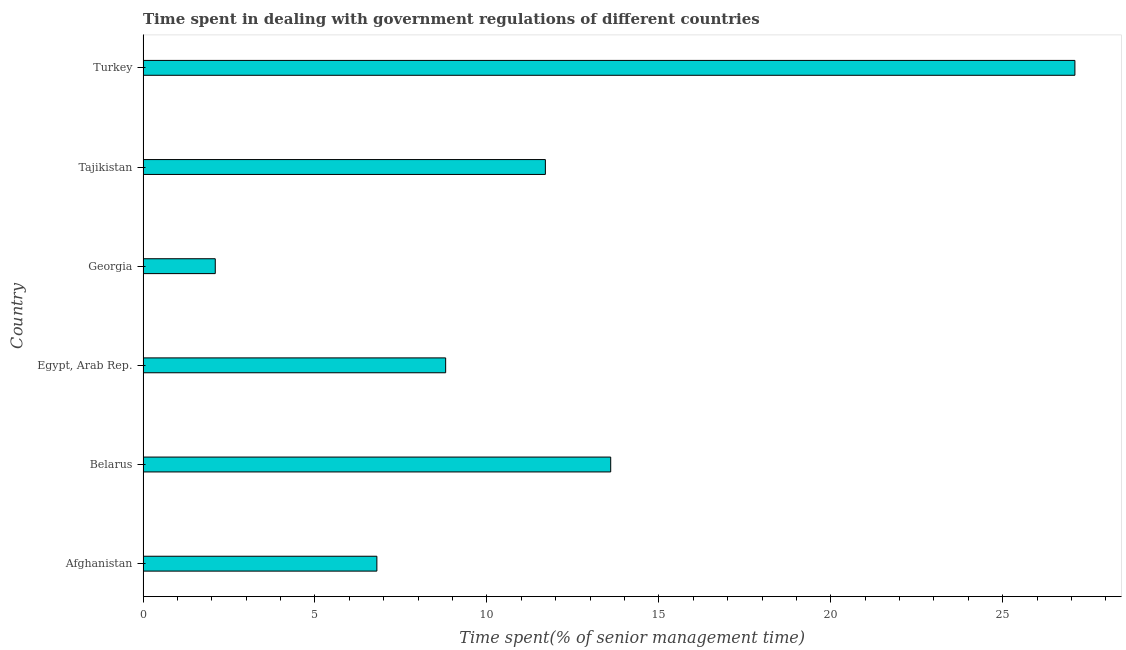Does the graph contain any zero values?
Keep it short and to the point. No. Does the graph contain grids?
Offer a terse response. No. What is the title of the graph?
Offer a terse response. Time spent in dealing with government regulations of different countries. What is the label or title of the X-axis?
Provide a succinct answer. Time spent(% of senior management time). What is the time spent in dealing with government regulations in Egypt, Arab Rep.?
Keep it short and to the point. 8.8. Across all countries, what is the maximum time spent in dealing with government regulations?
Provide a succinct answer. 27.1. In which country was the time spent in dealing with government regulations minimum?
Give a very brief answer. Georgia. What is the sum of the time spent in dealing with government regulations?
Your answer should be compact. 70.1. What is the difference between the time spent in dealing with government regulations in Egypt, Arab Rep. and Tajikistan?
Make the answer very short. -2.9. What is the average time spent in dealing with government regulations per country?
Your response must be concise. 11.68. What is the median time spent in dealing with government regulations?
Keep it short and to the point. 10.25. What is the ratio of the time spent in dealing with government regulations in Afghanistan to that in Georgia?
Your answer should be very brief. 3.24. Is the time spent in dealing with government regulations in Egypt, Arab Rep. less than that in Tajikistan?
Your answer should be compact. Yes. Is the difference between the time spent in dealing with government regulations in Afghanistan and Georgia greater than the difference between any two countries?
Keep it short and to the point. No. In how many countries, is the time spent in dealing with government regulations greater than the average time spent in dealing with government regulations taken over all countries?
Provide a succinct answer. 3. How many bars are there?
Your response must be concise. 6. What is the difference between two consecutive major ticks on the X-axis?
Your answer should be very brief. 5. What is the Time spent(% of senior management time) in Turkey?
Offer a very short reply. 27.1. What is the difference between the Time spent(% of senior management time) in Afghanistan and Georgia?
Give a very brief answer. 4.7. What is the difference between the Time spent(% of senior management time) in Afghanistan and Tajikistan?
Provide a short and direct response. -4.9. What is the difference between the Time spent(% of senior management time) in Afghanistan and Turkey?
Your answer should be compact. -20.3. What is the difference between the Time spent(% of senior management time) in Belarus and Egypt, Arab Rep.?
Ensure brevity in your answer.  4.8. What is the difference between the Time spent(% of senior management time) in Belarus and Turkey?
Ensure brevity in your answer.  -13.5. What is the difference between the Time spent(% of senior management time) in Egypt, Arab Rep. and Georgia?
Provide a succinct answer. 6.7. What is the difference between the Time spent(% of senior management time) in Egypt, Arab Rep. and Turkey?
Your answer should be very brief. -18.3. What is the difference between the Time spent(% of senior management time) in Tajikistan and Turkey?
Make the answer very short. -15.4. What is the ratio of the Time spent(% of senior management time) in Afghanistan to that in Belarus?
Your answer should be very brief. 0.5. What is the ratio of the Time spent(% of senior management time) in Afghanistan to that in Egypt, Arab Rep.?
Your answer should be very brief. 0.77. What is the ratio of the Time spent(% of senior management time) in Afghanistan to that in Georgia?
Your response must be concise. 3.24. What is the ratio of the Time spent(% of senior management time) in Afghanistan to that in Tajikistan?
Your answer should be very brief. 0.58. What is the ratio of the Time spent(% of senior management time) in Afghanistan to that in Turkey?
Make the answer very short. 0.25. What is the ratio of the Time spent(% of senior management time) in Belarus to that in Egypt, Arab Rep.?
Keep it short and to the point. 1.54. What is the ratio of the Time spent(% of senior management time) in Belarus to that in Georgia?
Provide a succinct answer. 6.48. What is the ratio of the Time spent(% of senior management time) in Belarus to that in Tajikistan?
Offer a very short reply. 1.16. What is the ratio of the Time spent(% of senior management time) in Belarus to that in Turkey?
Provide a short and direct response. 0.5. What is the ratio of the Time spent(% of senior management time) in Egypt, Arab Rep. to that in Georgia?
Offer a very short reply. 4.19. What is the ratio of the Time spent(% of senior management time) in Egypt, Arab Rep. to that in Tajikistan?
Provide a succinct answer. 0.75. What is the ratio of the Time spent(% of senior management time) in Egypt, Arab Rep. to that in Turkey?
Your response must be concise. 0.33. What is the ratio of the Time spent(% of senior management time) in Georgia to that in Tajikistan?
Your response must be concise. 0.18. What is the ratio of the Time spent(% of senior management time) in Georgia to that in Turkey?
Offer a terse response. 0.08. What is the ratio of the Time spent(% of senior management time) in Tajikistan to that in Turkey?
Ensure brevity in your answer.  0.43. 